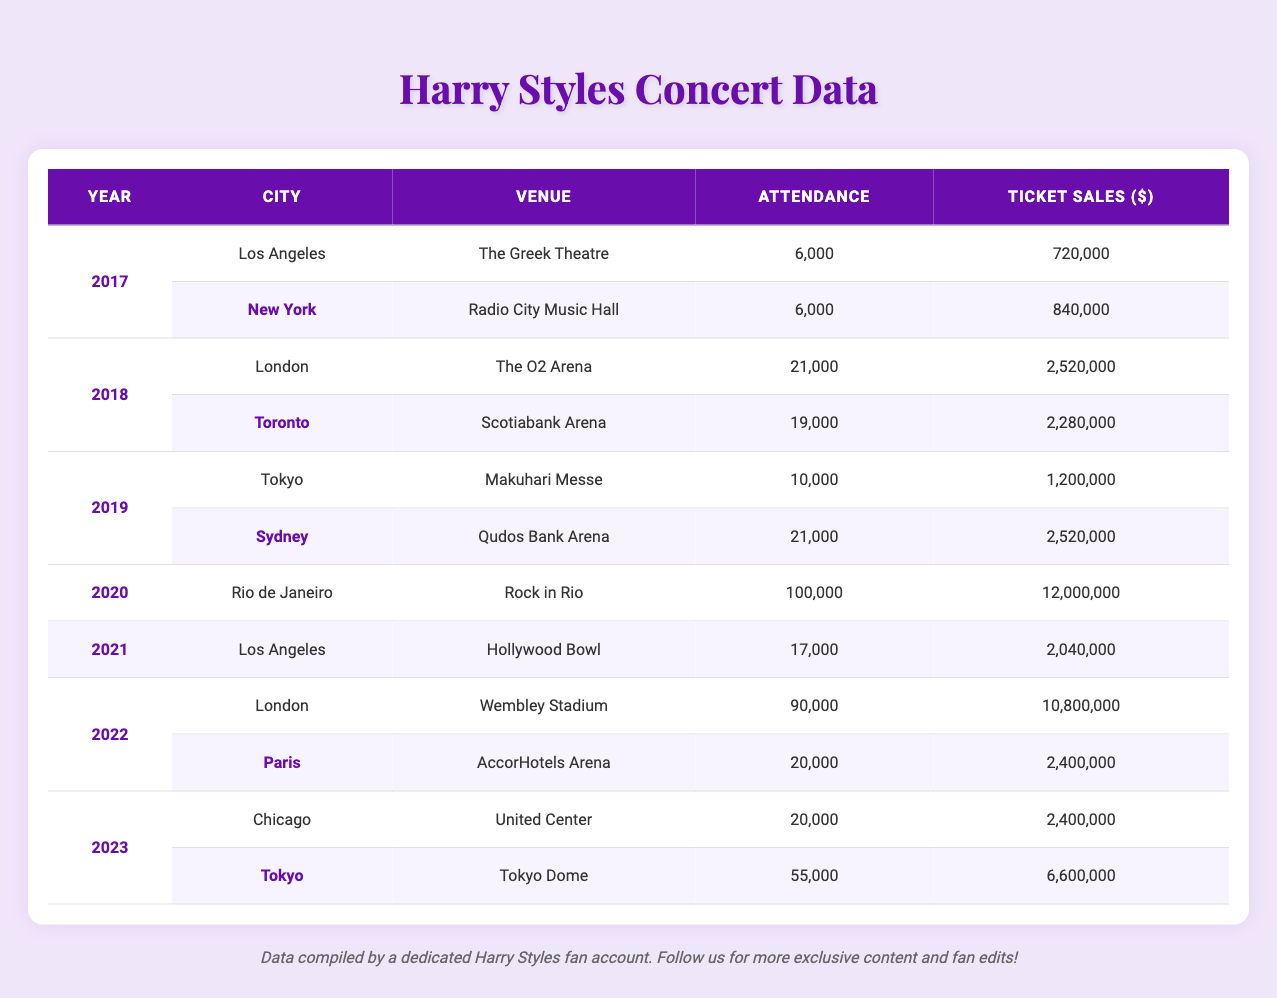What was the total attendance at Harry Styles concerts in 2018? In 2018, there were two concerts: one in London with an attendance of 21,000, and another in Toronto with 19,000. To find the total attendance, I add these two values: 21,000 + 19,000 = 40,000.
Answer: 40,000 Which city had the highest ticket sales in 2022? In 2022, there were two concerts: one in London with ticket sales of $10,800,000 and another in Paris with $2,400,000. Comparing these values, $10,800,000 is higher than $2,400,000, so London had the highest ticket sales.
Answer: London How many concerts did Harry Styles hold in 2019? In 2019, there were two concerts: one in Tokyo and one in Sydney. Therefore, the total number of concerts held in 2019 is 2.
Answer: 2 What was the average attendance per concert in 2020? In 2020, there was only one concert with an attendance of 100,000. Since there's only one concert, the average attendance is simply the attendance of that concert, which is 100,000.
Answer: 100,000 Which year had the highest total ticket sales? To find out which year had the highest total ticket sales, calculate the total for each year: 2017: 720,000 + 840,000 = 1,560,000; 2018: 2,520,000 + 2,280,000 = 4,800,000; 2019: 1,200,000 + 2,520,000 = 3,720,000; 2020: 12,000,000; 2021: 2,040,000; 2022: 10,800,000 + 2,400,000 = 13,200,000; 2023: 2,400,000 + 6,600,000 = 9,000,000. The year with the highest is 2022 with total sales of 13,200,000.
Answer: 2022 Is it true that Harry Styles performed in Chicago in 2023? According to the table, there is a concert listed in Chicago in 2023, so it is indeed true.
Answer: Yes What is the difference in attendance between the concerts in London in 2018 and 2022? The attendance at the London concert in 2018 was 21,000, and in 2022 it was 90,000. To find the difference, subtract the 2018 attendance from the 2022 attendance: 90,000 - 21,000 = 69,000.
Answer: 69,000 How many total ticket sales did Harry Styles make from all concerts in 2017? In 2017, the ticket sales totals were $720,000 for Los Angeles and $840,000 for New York. Add these together: 720,000 + 840,000 = 1,560,000.
Answer: 1,560,000 Which venue had the highest attendance in 2023? In 2023, there were two concerts: one in Chicago with an attendance of 20,000 and another in Tokyo with 55,000. The Tokyo Dome had the highest attendance.
Answer: Tokyo Dome What can be said about Harry Styles's ticket sales trend over the years? Examining the yearly total ticket sales: 2017: 1,560,000; 2018: 4,800,000; 2019: 3,720,000; 2020: 12,000,000; 2021: 2,040,000; 2022: 13,200,000; 2023: 9,000,000. The sales fluctuated, peaking significantly in 2020 and 2022, which indicates a strong upward trend despite some annual dips.
Answer: Fluctuating upward trend What is the total attendance of all concerts from 2017 to 2020? Calculate total attendance for each year: 2017: 6,000 + 6,000 = 12,000; 2018: 21,000 + 19,000 = 40,000; 2019: 10,000 + 21,000 = 31,000; 2020: 100,000. Now add these totals: 12,000 + 40,000 + 31,000 + 100,000 = 183,000.
Answer: 183,000 